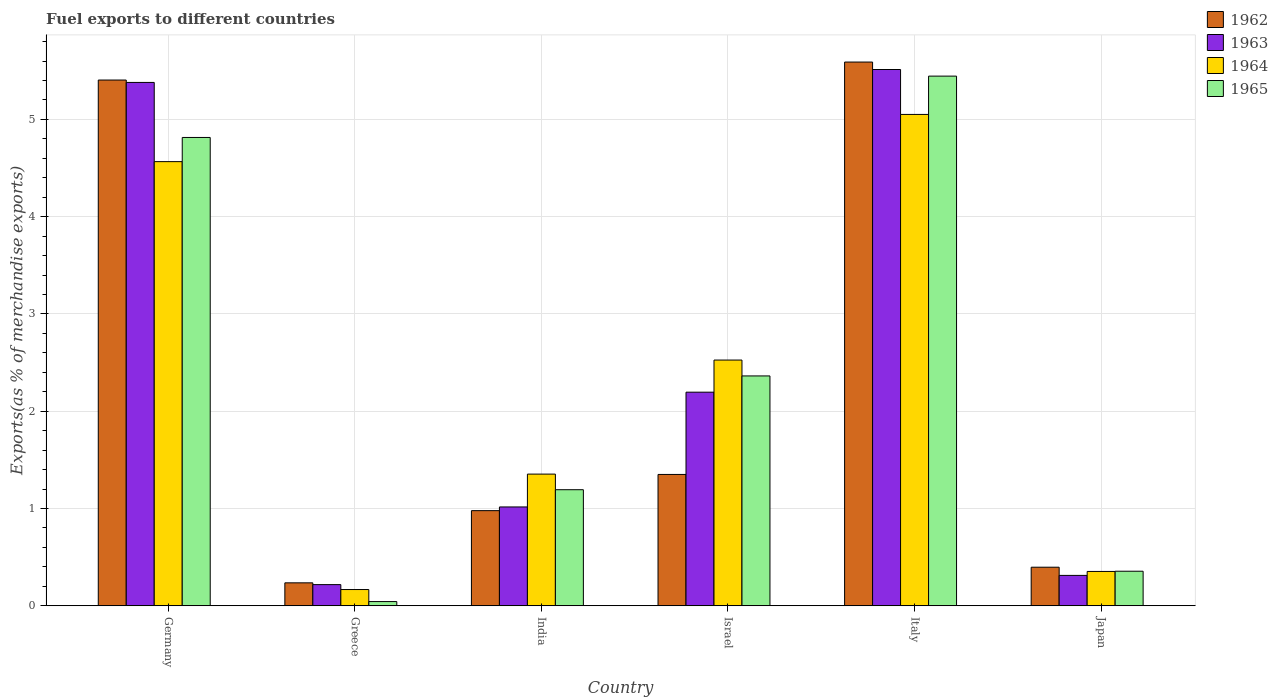Are the number of bars per tick equal to the number of legend labels?
Your response must be concise. Yes. How many bars are there on the 6th tick from the right?
Offer a very short reply. 4. What is the percentage of exports to different countries in 1965 in India?
Keep it short and to the point. 1.19. Across all countries, what is the maximum percentage of exports to different countries in 1963?
Your answer should be very brief. 5.51. Across all countries, what is the minimum percentage of exports to different countries in 1965?
Your answer should be compact. 0.04. In which country was the percentage of exports to different countries in 1962 maximum?
Make the answer very short. Italy. What is the total percentage of exports to different countries in 1965 in the graph?
Ensure brevity in your answer.  14.21. What is the difference between the percentage of exports to different countries in 1962 in Greece and that in Italy?
Your answer should be very brief. -5.35. What is the difference between the percentage of exports to different countries in 1964 in Italy and the percentage of exports to different countries in 1963 in India?
Provide a succinct answer. 4.04. What is the average percentage of exports to different countries in 1962 per country?
Provide a short and direct response. 2.33. What is the difference between the percentage of exports to different countries of/in 1964 and percentage of exports to different countries of/in 1963 in Israel?
Keep it short and to the point. 0.33. What is the ratio of the percentage of exports to different countries in 1965 in Israel to that in Japan?
Your answer should be compact. 6.65. Is the percentage of exports to different countries in 1962 in Germany less than that in India?
Keep it short and to the point. No. Is the difference between the percentage of exports to different countries in 1964 in India and Japan greater than the difference between the percentage of exports to different countries in 1963 in India and Japan?
Provide a short and direct response. Yes. What is the difference between the highest and the second highest percentage of exports to different countries in 1963?
Offer a terse response. 3.18. What is the difference between the highest and the lowest percentage of exports to different countries in 1963?
Give a very brief answer. 5.3. In how many countries, is the percentage of exports to different countries in 1962 greater than the average percentage of exports to different countries in 1962 taken over all countries?
Offer a terse response. 2. Is the sum of the percentage of exports to different countries in 1964 in Germany and Japan greater than the maximum percentage of exports to different countries in 1963 across all countries?
Ensure brevity in your answer.  No. What does the 1st bar from the left in Israel represents?
Ensure brevity in your answer.  1962. What does the 3rd bar from the right in Germany represents?
Provide a short and direct response. 1963. How many bars are there?
Your answer should be very brief. 24. How many countries are there in the graph?
Your answer should be very brief. 6. Are the values on the major ticks of Y-axis written in scientific E-notation?
Provide a short and direct response. No. Does the graph contain any zero values?
Your answer should be very brief. No. Where does the legend appear in the graph?
Make the answer very short. Top right. How many legend labels are there?
Keep it short and to the point. 4. How are the legend labels stacked?
Your answer should be compact. Vertical. What is the title of the graph?
Your answer should be very brief. Fuel exports to different countries. What is the label or title of the X-axis?
Make the answer very short. Country. What is the label or title of the Y-axis?
Your answer should be compact. Exports(as % of merchandise exports). What is the Exports(as % of merchandise exports) of 1962 in Germany?
Your answer should be very brief. 5.4. What is the Exports(as % of merchandise exports) in 1963 in Germany?
Give a very brief answer. 5.38. What is the Exports(as % of merchandise exports) in 1964 in Germany?
Give a very brief answer. 4.57. What is the Exports(as % of merchandise exports) in 1965 in Germany?
Offer a very short reply. 4.81. What is the Exports(as % of merchandise exports) in 1962 in Greece?
Offer a terse response. 0.24. What is the Exports(as % of merchandise exports) in 1963 in Greece?
Offer a very short reply. 0.22. What is the Exports(as % of merchandise exports) in 1964 in Greece?
Your answer should be very brief. 0.17. What is the Exports(as % of merchandise exports) in 1965 in Greece?
Keep it short and to the point. 0.04. What is the Exports(as % of merchandise exports) in 1962 in India?
Offer a very short reply. 0.98. What is the Exports(as % of merchandise exports) of 1963 in India?
Keep it short and to the point. 1.02. What is the Exports(as % of merchandise exports) of 1964 in India?
Give a very brief answer. 1.35. What is the Exports(as % of merchandise exports) of 1965 in India?
Make the answer very short. 1.19. What is the Exports(as % of merchandise exports) in 1962 in Israel?
Provide a succinct answer. 1.35. What is the Exports(as % of merchandise exports) of 1963 in Israel?
Make the answer very short. 2.2. What is the Exports(as % of merchandise exports) in 1964 in Israel?
Provide a succinct answer. 2.53. What is the Exports(as % of merchandise exports) of 1965 in Israel?
Provide a short and direct response. 2.36. What is the Exports(as % of merchandise exports) of 1962 in Italy?
Keep it short and to the point. 5.59. What is the Exports(as % of merchandise exports) in 1963 in Italy?
Your answer should be very brief. 5.51. What is the Exports(as % of merchandise exports) of 1964 in Italy?
Keep it short and to the point. 5.05. What is the Exports(as % of merchandise exports) in 1965 in Italy?
Keep it short and to the point. 5.45. What is the Exports(as % of merchandise exports) in 1962 in Japan?
Offer a very short reply. 0.4. What is the Exports(as % of merchandise exports) in 1963 in Japan?
Give a very brief answer. 0.31. What is the Exports(as % of merchandise exports) in 1964 in Japan?
Your answer should be compact. 0.35. What is the Exports(as % of merchandise exports) in 1965 in Japan?
Give a very brief answer. 0.36. Across all countries, what is the maximum Exports(as % of merchandise exports) of 1962?
Ensure brevity in your answer.  5.59. Across all countries, what is the maximum Exports(as % of merchandise exports) in 1963?
Keep it short and to the point. 5.51. Across all countries, what is the maximum Exports(as % of merchandise exports) of 1964?
Ensure brevity in your answer.  5.05. Across all countries, what is the maximum Exports(as % of merchandise exports) of 1965?
Your answer should be compact. 5.45. Across all countries, what is the minimum Exports(as % of merchandise exports) in 1962?
Provide a short and direct response. 0.24. Across all countries, what is the minimum Exports(as % of merchandise exports) of 1963?
Your answer should be very brief. 0.22. Across all countries, what is the minimum Exports(as % of merchandise exports) of 1964?
Keep it short and to the point. 0.17. Across all countries, what is the minimum Exports(as % of merchandise exports) in 1965?
Make the answer very short. 0.04. What is the total Exports(as % of merchandise exports) in 1962 in the graph?
Offer a terse response. 13.96. What is the total Exports(as % of merchandise exports) of 1963 in the graph?
Your response must be concise. 14.64. What is the total Exports(as % of merchandise exports) in 1964 in the graph?
Provide a succinct answer. 14.02. What is the total Exports(as % of merchandise exports) of 1965 in the graph?
Provide a short and direct response. 14.21. What is the difference between the Exports(as % of merchandise exports) of 1962 in Germany and that in Greece?
Ensure brevity in your answer.  5.17. What is the difference between the Exports(as % of merchandise exports) of 1963 in Germany and that in Greece?
Offer a very short reply. 5.16. What is the difference between the Exports(as % of merchandise exports) of 1964 in Germany and that in Greece?
Give a very brief answer. 4.4. What is the difference between the Exports(as % of merchandise exports) of 1965 in Germany and that in Greece?
Your answer should be very brief. 4.77. What is the difference between the Exports(as % of merchandise exports) of 1962 in Germany and that in India?
Offer a very short reply. 4.43. What is the difference between the Exports(as % of merchandise exports) in 1963 in Germany and that in India?
Ensure brevity in your answer.  4.36. What is the difference between the Exports(as % of merchandise exports) of 1964 in Germany and that in India?
Ensure brevity in your answer.  3.21. What is the difference between the Exports(as % of merchandise exports) of 1965 in Germany and that in India?
Make the answer very short. 3.62. What is the difference between the Exports(as % of merchandise exports) of 1962 in Germany and that in Israel?
Your answer should be compact. 4.05. What is the difference between the Exports(as % of merchandise exports) of 1963 in Germany and that in Israel?
Offer a terse response. 3.18. What is the difference between the Exports(as % of merchandise exports) of 1964 in Germany and that in Israel?
Ensure brevity in your answer.  2.04. What is the difference between the Exports(as % of merchandise exports) in 1965 in Germany and that in Israel?
Ensure brevity in your answer.  2.45. What is the difference between the Exports(as % of merchandise exports) in 1962 in Germany and that in Italy?
Provide a short and direct response. -0.18. What is the difference between the Exports(as % of merchandise exports) in 1963 in Germany and that in Italy?
Your answer should be very brief. -0.13. What is the difference between the Exports(as % of merchandise exports) of 1964 in Germany and that in Italy?
Give a very brief answer. -0.49. What is the difference between the Exports(as % of merchandise exports) in 1965 in Germany and that in Italy?
Make the answer very short. -0.63. What is the difference between the Exports(as % of merchandise exports) of 1962 in Germany and that in Japan?
Your answer should be compact. 5.01. What is the difference between the Exports(as % of merchandise exports) of 1963 in Germany and that in Japan?
Keep it short and to the point. 5.07. What is the difference between the Exports(as % of merchandise exports) of 1964 in Germany and that in Japan?
Your answer should be compact. 4.21. What is the difference between the Exports(as % of merchandise exports) in 1965 in Germany and that in Japan?
Provide a succinct answer. 4.46. What is the difference between the Exports(as % of merchandise exports) of 1962 in Greece and that in India?
Your answer should be compact. -0.74. What is the difference between the Exports(as % of merchandise exports) in 1963 in Greece and that in India?
Your response must be concise. -0.8. What is the difference between the Exports(as % of merchandise exports) in 1964 in Greece and that in India?
Your answer should be very brief. -1.19. What is the difference between the Exports(as % of merchandise exports) of 1965 in Greece and that in India?
Provide a succinct answer. -1.15. What is the difference between the Exports(as % of merchandise exports) of 1962 in Greece and that in Israel?
Offer a very short reply. -1.11. What is the difference between the Exports(as % of merchandise exports) of 1963 in Greece and that in Israel?
Give a very brief answer. -1.98. What is the difference between the Exports(as % of merchandise exports) of 1964 in Greece and that in Israel?
Your answer should be very brief. -2.36. What is the difference between the Exports(as % of merchandise exports) in 1965 in Greece and that in Israel?
Provide a succinct answer. -2.32. What is the difference between the Exports(as % of merchandise exports) in 1962 in Greece and that in Italy?
Offer a very short reply. -5.35. What is the difference between the Exports(as % of merchandise exports) in 1963 in Greece and that in Italy?
Your answer should be compact. -5.3. What is the difference between the Exports(as % of merchandise exports) in 1964 in Greece and that in Italy?
Give a very brief answer. -4.88. What is the difference between the Exports(as % of merchandise exports) in 1965 in Greece and that in Italy?
Offer a very short reply. -5.4. What is the difference between the Exports(as % of merchandise exports) in 1962 in Greece and that in Japan?
Keep it short and to the point. -0.16. What is the difference between the Exports(as % of merchandise exports) of 1963 in Greece and that in Japan?
Ensure brevity in your answer.  -0.09. What is the difference between the Exports(as % of merchandise exports) in 1964 in Greece and that in Japan?
Make the answer very short. -0.19. What is the difference between the Exports(as % of merchandise exports) of 1965 in Greece and that in Japan?
Your answer should be very brief. -0.31. What is the difference between the Exports(as % of merchandise exports) of 1962 in India and that in Israel?
Keep it short and to the point. -0.37. What is the difference between the Exports(as % of merchandise exports) in 1963 in India and that in Israel?
Provide a succinct answer. -1.18. What is the difference between the Exports(as % of merchandise exports) of 1964 in India and that in Israel?
Provide a succinct answer. -1.17. What is the difference between the Exports(as % of merchandise exports) in 1965 in India and that in Israel?
Your answer should be very brief. -1.17. What is the difference between the Exports(as % of merchandise exports) in 1962 in India and that in Italy?
Provide a short and direct response. -4.61. What is the difference between the Exports(as % of merchandise exports) in 1963 in India and that in Italy?
Your response must be concise. -4.5. What is the difference between the Exports(as % of merchandise exports) of 1964 in India and that in Italy?
Your answer should be compact. -3.7. What is the difference between the Exports(as % of merchandise exports) in 1965 in India and that in Italy?
Provide a short and direct response. -4.25. What is the difference between the Exports(as % of merchandise exports) in 1962 in India and that in Japan?
Ensure brevity in your answer.  0.58. What is the difference between the Exports(as % of merchandise exports) in 1963 in India and that in Japan?
Your answer should be very brief. 0.7. What is the difference between the Exports(as % of merchandise exports) in 1965 in India and that in Japan?
Offer a terse response. 0.84. What is the difference between the Exports(as % of merchandise exports) in 1962 in Israel and that in Italy?
Keep it short and to the point. -4.24. What is the difference between the Exports(as % of merchandise exports) of 1963 in Israel and that in Italy?
Your response must be concise. -3.32. What is the difference between the Exports(as % of merchandise exports) of 1964 in Israel and that in Italy?
Ensure brevity in your answer.  -2.53. What is the difference between the Exports(as % of merchandise exports) of 1965 in Israel and that in Italy?
Your answer should be compact. -3.08. What is the difference between the Exports(as % of merchandise exports) in 1962 in Israel and that in Japan?
Your answer should be compact. 0.95. What is the difference between the Exports(as % of merchandise exports) of 1963 in Israel and that in Japan?
Provide a short and direct response. 1.88. What is the difference between the Exports(as % of merchandise exports) of 1964 in Israel and that in Japan?
Make the answer very short. 2.17. What is the difference between the Exports(as % of merchandise exports) of 1965 in Israel and that in Japan?
Keep it short and to the point. 2.01. What is the difference between the Exports(as % of merchandise exports) of 1962 in Italy and that in Japan?
Your answer should be very brief. 5.19. What is the difference between the Exports(as % of merchandise exports) of 1963 in Italy and that in Japan?
Your answer should be compact. 5.2. What is the difference between the Exports(as % of merchandise exports) of 1964 in Italy and that in Japan?
Make the answer very short. 4.7. What is the difference between the Exports(as % of merchandise exports) in 1965 in Italy and that in Japan?
Give a very brief answer. 5.09. What is the difference between the Exports(as % of merchandise exports) in 1962 in Germany and the Exports(as % of merchandise exports) in 1963 in Greece?
Provide a succinct answer. 5.19. What is the difference between the Exports(as % of merchandise exports) in 1962 in Germany and the Exports(as % of merchandise exports) in 1964 in Greece?
Ensure brevity in your answer.  5.24. What is the difference between the Exports(as % of merchandise exports) of 1962 in Germany and the Exports(as % of merchandise exports) of 1965 in Greece?
Provide a short and direct response. 5.36. What is the difference between the Exports(as % of merchandise exports) of 1963 in Germany and the Exports(as % of merchandise exports) of 1964 in Greece?
Provide a short and direct response. 5.21. What is the difference between the Exports(as % of merchandise exports) in 1963 in Germany and the Exports(as % of merchandise exports) in 1965 in Greece?
Keep it short and to the point. 5.34. What is the difference between the Exports(as % of merchandise exports) in 1964 in Germany and the Exports(as % of merchandise exports) in 1965 in Greece?
Your answer should be very brief. 4.52. What is the difference between the Exports(as % of merchandise exports) of 1962 in Germany and the Exports(as % of merchandise exports) of 1963 in India?
Ensure brevity in your answer.  4.39. What is the difference between the Exports(as % of merchandise exports) of 1962 in Germany and the Exports(as % of merchandise exports) of 1964 in India?
Make the answer very short. 4.05. What is the difference between the Exports(as % of merchandise exports) of 1962 in Germany and the Exports(as % of merchandise exports) of 1965 in India?
Give a very brief answer. 4.21. What is the difference between the Exports(as % of merchandise exports) of 1963 in Germany and the Exports(as % of merchandise exports) of 1964 in India?
Provide a short and direct response. 4.03. What is the difference between the Exports(as % of merchandise exports) in 1963 in Germany and the Exports(as % of merchandise exports) in 1965 in India?
Keep it short and to the point. 4.19. What is the difference between the Exports(as % of merchandise exports) in 1964 in Germany and the Exports(as % of merchandise exports) in 1965 in India?
Ensure brevity in your answer.  3.37. What is the difference between the Exports(as % of merchandise exports) of 1962 in Germany and the Exports(as % of merchandise exports) of 1963 in Israel?
Provide a succinct answer. 3.21. What is the difference between the Exports(as % of merchandise exports) in 1962 in Germany and the Exports(as % of merchandise exports) in 1964 in Israel?
Your answer should be compact. 2.88. What is the difference between the Exports(as % of merchandise exports) in 1962 in Germany and the Exports(as % of merchandise exports) in 1965 in Israel?
Your response must be concise. 3.04. What is the difference between the Exports(as % of merchandise exports) in 1963 in Germany and the Exports(as % of merchandise exports) in 1964 in Israel?
Ensure brevity in your answer.  2.85. What is the difference between the Exports(as % of merchandise exports) of 1963 in Germany and the Exports(as % of merchandise exports) of 1965 in Israel?
Your response must be concise. 3.02. What is the difference between the Exports(as % of merchandise exports) of 1964 in Germany and the Exports(as % of merchandise exports) of 1965 in Israel?
Make the answer very short. 2.2. What is the difference between the Exports(as % of merchandise exports) of 1962 in Germany and the Exports(as % of merchandise exports) of 1963 in Italy?
Give a very brief answer. -0.11. What is the difference between the Exports(as % of merchandise exports) in 1962 in Germany and the Exports(as % of merchandise exports) in 1964 in Italy?
Keep it short and to the point. 0.35. What is the difference between the Exports(as % of merchandise exports) in 1962 in Germany and the Exports(as % of merchandise exports) in 1965 in Italy?
Keep it short and to the point. -0.04. What is the difference between the Exports(as % of merchandise exports) of 1963 in Germany and the Exports(as % of merchandise exports) of 1964 in Italy?
Offer a very short reply. 0.33. What is the difference between the Exports(as % of merchandise exports) of 1963 in Germany and the Exports(as % of merchandise exports) of 1965 in Italy?
Offer a very short reply. -0.06. What is the difference between the Exports(as % of merchandise exports) of 1964 in Germany and the Exports(as % of merchandise exports) of 1965 in Italy?
Your answer should be compact. -0.88. What is the difference between the Exports(as % of merchandise exports) of 1962 in Germany and the Exports(as % of merchandise exports) of 1963 in Japan?
Offer a very short reply. 5.09. What is the difference between the Exports(as % of merchandise exports) of 1962 in Germany and the Exports(as % of merchandise exports) of 1964 in Japan?
Your answer should be compact. 5.05. What is the difference between the Exports(as % of merchandise exports) in 1962 in Germany and the Exports(as % of merchandise exports) in 1965 in Japan?
Provide a short and direct response. 5.05. What is the difference between the Exports(as % of merchandise exports) of 1963 in Germany and the Exports(as % of merchandise exports) of 1964 in Japan?
Make the answer very short. 5.03. What is the difference between the Exports(as % of merchandise exports) of 1963 in Germany and the Exports(as % of merchandise exports) of 1965 in Japan?
Ensure brevity in your answer.  5.03. What is the difference between the Exports(as % of merchandise exports) in 1964 in Germany and the Exports(as % of merchandise exports) in 1965 in Japan?
Your answer should be compact. 4.21. What is the difference between the Exports(as % of merchandise exports) of 1962 in Greece and the Exports(as % of merchandise exports) of 1963 in India?
Make the answer very short. -0.78. What is the difference between the Exports(as % of merchandise exports) of 1962 in Greece and the Exports(as % of merchandise exports) of 1964 in India?
Offer a very short reply. -1.12. What is the difference between the Exports(as % of merchandise exports) in 1962 in Greece and the Exports(as % of merchandise exports) in 1965 in India?
Keep it short and to the point. -0.96. What is the difference between the Exports(as % of merchandise exports) of 1963 in Greece and the Exports(as % of merchandise exports) of 1964 in India?
Ensure brevity in your answer.  -1.14. What is the difference between the Exports(as % of merchandise exports) of 1963 in Greece and the Exports(as % of merchandise exports) of 1965 in India?
Provide a succinct answer. -0.98. What is the difference between the Exports(as % of merchandise exports) of 1964 in Greece and the Exports(as % of merchandise exports) of 1965 in India?
Offer a terse response. -1.03. What is the difference between the Exports(as % of merchandise exports) of 1962 in Greece and the Exports(as % of merchandise exports) of 1963 in Israel?
Make the answer very short. -1.96. What is the difference between the Exports(as % of merchandise exports) in 1962 in Greece and the Exports(as % of merchandise exports) in 1964 in Israel?
Give a very brief answer. -2.29. What is the difference between the Exports(as % of merchandise exports) in 1962 in Greece and the Exports(as % of merchandise exports) in 1965 in Israel?
Offer a terse response. -2.13. What is the difference between the Exports(as % of merchandise exports) in 1963 in Greece and the Exports(as % of merchandise exports) in 1964 in Israel?
Provide a succinct answer. -2.31. What is the difference between the Exports(as % of merchandise exports) in 1963 in Greece and the Exports(as % of merchandise exports) in 1965 in Israel?
Make the answer very short. -2.15. What is the difference between the Exports(as % of merchandise exports) in 1964 in Greece and the Exports(as % of merchandise exports) in 1965 in Israel?
Your response must be concise. -2.2. What is the difference between the Exports(as % of merchandise exports) in 1962 in Greece and the Exports(as % of merchandise exports) in 1963 in Italy?
Provide a succinct answer. -5.28. What is the difference between the Exports(as % of merchandise exports) in 1962 in Greece and the Exports(as % of merchandise exports) in 1964 in Italy?
Your answer should be compact. -4.82. What is the difference between the Exports(as % of merchandise exports) of 1962 in Greece and the Exports(as % of merchandise exports) of 1965 in Italy?
Make the answer very short. -5.21. What is the difference between the Exports(as % of merchandise exports) of 1963 in Greece and the Exports(as % of merchandise exports) of 1964 in Italy?
Your answer should be compact. -4.83. What is the difference between the Exports(as % of merchandise exports) of 1963 in Greece and the Exports(as % of merchandise exports) of 1965 in Italy?
Make the answer very short. -5.23. What is the difference between the Exports(as % of merchandise exports) of 1964 in Greece and the Exports(as % of merchandise exports) of 1965 in Italy?
Offer a very short reply. -5.28. What is the difference between the Exports(as % of merchandise exports) in 1962 in Greece and the Exports(as % of merchandise exports) in 1963 in Japan?
Provide a short and direct response. -0.08. What is the difference between the Exports(as % of merchandise exports) in 1962 in Greece and the Exports(as % of merchandise exports) in 1964 in Japan?
Give a very brief answer. -0.12. What is the difference between the Exports(as % of merchandise exports) of 1962 in Greece and the Exports(as % of merchandise exports) of 1965 in Japan?
Ensure brevity in your answer.  -0.12. What is the difference between the Exports(as % of merchandise exports) in 1963 in Greece and the Exports(as % of merchandise exports) in 1964 in Japan?
Give a very brief answer. -0.14. What is the difference between the Exports(as % of merchandise exports) in 1963 in Greece and the Exports(as % of merchandise exports) in 1965 in Japan?
Your answer should be very brief. -0.14. What is the difference between the Exports(as % of merchandise exports) in 1964 in Greece and the Exports(as % of merchandise exports) in 1965 in Japan?
Your answer should be compact. -0.19. What is the difference between the Exports(as % of merchandise exports) in 1962 in India and the Exports(as % of merchandise exports) in 1963 in Israel?
Keep it short and to the point. -1.22. What is the difference between the Exports(as % of merchandise exports) of 1962 in India and the Exports(as % of merchandise exports) of 1964 in Israel?
Provide a succinct answer. -1.55. What is the difference between the Exports(as % of merchandise exports) in 1962 in India and the Exports(as % of merchandise exports) in 1965 in Israel?
Offer a terse response. -1.38. What is the difference between the Exports(as % of merchandise exports) of 1963 in India and the Exports(as % of merchandise exports) of 1964 in Israel?
Give a very brief answer. -1.51. What is the difference between the Exports(as % of merchandise exports) in 1963 in India and the Exports(as % of merchandise exports) in 1965 in Israel?
Keep it short and to the point. -1.35. What is the difference between the Exports(as % of merchandise exports) of 1964 in India and the Exports(as % of merchandise exports) of 1965 in Israel?
Your response must be concise. -1.01. What is the difference between the Exports(as % of merchandise exports) in 1962 in India and the Exports(as % of merchandise exports) in 1963 in Italy?
Keep it short and to the point. -4.54. What is the difference between the Exports(as % of merchandise exports) of 1962 in India and the Exports(as % of merchandise exports) of 1964 in Italy?
Make the answer very short. -4.07. What is the difference between the Exports(as % of merchandise exports) in 1962 in India and the Exports(as % of merchandise exports) in 1965 in Italy?
Offer a terse response. -4.47. What is the difference between the Exports(as % of merchandise exports) in 1963 in India and the Exports(as % of merchandise exports) in 1964 in Italy?
Make the answer very short. -4.04. What is the difference between the Exports(as % of merchandise exports) of 1963 in India and the Exports(as % of merchandise exports) of 1965 in Italy?
Your answer should be very brief. -4.43. What is the difference between the Exports(as % of merchandise exports) in 1964 in India and the Exports(as % of merchandise exports) in 1965 in Italy?
Offer a terse response. -4.09. What is the difference between the Exports(as % of merchandise exports) in 1962 in India and the Exports(as % of merchandise exports) in 1963 in Japan?
Provide a short and direct response. 0.67. What is the difference between the Exports(as % of merchandise exports) in 1962 in India and the Exports(as % of merchandise exports) in 1964 in Japan?
Your answer should be very brief. 0.63. What is the difference between the Exports(as % of merchandise exports) in 1962 in India and the Exports(as % of merchandise exports) in 1965 in Japan?
Provide a short and direct response. 0.62. What is the difference between the Exports(as % of merchandise exports) in 1963 in India and the Exports(as % of merchandise exports) in 1964 in Japan?
Give a very brief answer. 0.66. What is the difference between the Exports(as % of merchandise exports) of 1963 in India and the Exports(as % of merchandise exports) of 1965 in Japan?
Provide a succinct answer. 0.66. What is the difference between the Exports(as % of merchandise exports) of 1964 in India and the Exports(as % of merchandise exports) of 1965 in Japan?
Keep it short and to the point. 1. What is the difference between the Exports(as % of merchandise exports) in 1962 in Israel and the Exports(as % of merchandise exports) in 1963 in Italy?
Offer a terse response. -4.16. What is the difference between the Exports(as % of merchandise exports) in 1962 in Israel and the Exports(as % of merchandise exports) in 1964 in Italy?
Your response must be concise. -3.7. What is the difference between the Exports(as % of merchandise exports) of 1962 in Israel and the Exports(as % of merchandise exports) of 1965 in Italy?
Offer a terse response. -4.09. What is the difference between the Exports(as % of merchandise exports) in 1963 in Israel and the Exports(as % of merchandise exports) in 1964 in Italy?
Provide a succinct answer. -2.86. What is the difference between the Exports(as % of merchandise exports) of 1963 in Israel and the Exports(as % of merchandise exports) of 1965 in Italy?
Offer a very short reply. -3.25. What is the difference between the Exports(as % of merchandise exports) in 1964 in Israel and the Exports(as % of merchandise exports) in 1965 in Italy?
Provide a succinct answer. -2.92. What is the difference between the Exports(as % of merchandise exports) in 1962 in Israel and the Exports(as % of merchandise exports) in 1963 in Japan?
Provide a short and direct response. 1.04. What is the difference between the Exports(as % of merchandise exports) in 1962 in Israel and the Exports(as % of merchandise exports) in 1964 in Japan?
Your answer should be very brief. 1. What is the difference between the Exports(as % of merchandise exports) in 1963 in Israel and the Exports(as % of merchandise exports) in 1964 in Japan?
Provide a short and direct response. 1.84. What is the difference between the Exports(as % of merchandise exports) in 1963 in Israel and the Exports(as % of merchandise exports) in 1965 in Japan?
Make the answer very short. 1.84. What is the difference between the Exports(as % of merchandise exports) of 1964 in Israel and the Exports(as % of merchandise exports) of 1965 in Japan?
Offer a terse response. 2.17. What is the difference between the Exports(as % of merchandise exports) in 1962 in Italy and the Exports(as % of merchandise exports) in 1963 in Japan?
Offer a terse response. 5.28. What is the difference between the Exports(as % of merchandise exports) in 1962 in Italy and the Exports(as % of merchandise exports) in 1964 in Japan?
Make the answer very short. 5.24. What is the difference between the Exports(as % of merchandise exports) of 1962 in Italy and the Exports(as % of merchandise exports) of 1965 in Japan?
Offer a terse response. 5.23. What is the difference between the Exports(as % of merchandise exports) of 1963 in Italy and the Exports(as % of merchandise exports) of 1964 in Japan?
Offer a terse response. 5.16. What is the difference between the Exports(as % of merchandise exports) in 1963 in Italy and the Exports(as % of merchandise exports) in 1965 in Japan?
Keep it short and to the point. 5.16. What is the difference between the Exports(as % of merchandise exports) of 1964 in Italy and the Exports(as % of merchandise exports) of 1965 in Japan?
Your answer should be very brief. 4.7. What is the average Exports(as % of merchandise exports) of 1962 per country?
Your answer should be very brief. 2.33. What is the average Exports(as % of merchandise exports) in 1963 per country?
Keep it short and to the point. 2.44. What is the average Exports(as % of merchandise exports) of 1964 per country?
Offer a terse response. 2.34. What is the average Exports(as % of merchandise exports) of 1965 per country?
Make the answer very short. 2.37. What is the difference between the Exports(as % of merchandise exports) in 1962 and Exports(as % of merchandise exports) in 1963 in Germany?
Your answer should be compact. 0.02. What is the difference between the Exports(as % of merchandise exports) in 1962 and Exports(as % of merchandise exports) in 1964 in Germany?
Make the answer very short. 0.84. What is the difference between the Exports(as % of merchandise exports) of 1962 and Exports(as % of merchandise exports) of 1965 in Germany?
Make the answer very short. 0.59. What is the difference between the Exports(as % of merchandise exports) of 1963 and Exports(as % of merchandise exports) of 1964 in Germany?
Provide a short and direct response. 0.81. What is the difference between the Exports(as % of merchandise exports) in 1963 and Exports(as % of merchandise exports) in 1965 in Germany?
Keep it short and to the point. 0.57. What is the difference between the Exports(as % of merchandise exports) in 1964 and Exports(as % of merchandise exports) in 1965 in Germany?
Make the answer very short. -0.25. What is the difference between the Exports(as % of merchandise exports) in 1962 and Exports(as % of merchandise exports) in 1963 in Greece?
Your answer should be compact. 0.02. What is the difference between the Exports(as % of merchandise exports) in 1962 and Exports(as % of merchandise exports) in 1964 in Greece?
Ensure brevity in your answer.  0.07. What is the difference between the Exports(as % of merchandise exports) of 1962 and Exports(as % of merchandise exports) of 1965 in Greece?
Your response must be concise. 0.19. What is the difference between the Exports(as % of merchandise exports) of 1963 and Exports(as % of merchandise exports) of 1964 in Greece?
Ensure brevity in your answer.  0.05. What is the difference between the Exports(as % of merchandise exports) in 1963 and Exports(as % of merchandise exports) in 1965 in Greece?
Provide a short and direct response. 0.17. What is the difference between the Exports(as % of merchandise exports) of 1964 and Exports(as % of merchandise exports) of 1965 in Greece?
Offer a terse response. 0.12. What is the difference between the Exports(as % of merchandise exports) of 1962 and Exports(as % of merchandise exports) of 1963 in India?
Provide a short and direct response. -0.04. What is the difference between the Exports(as % of merchandise exports) in 1962 and Exports(as % of merchandise exports) in 1964 in India?
Ensure brevity in your answer.  -0.38. What is the difference between the Exports(as % of merchandise exports) of 1962 and Exports(as % of merchandise exports) of 1965 in India?
Provide a succinct answer. -0.22. What is the difference between the Exports(as % of merchandise exports) of 1963 and Exports(as % of merchandise exports) of 1964 in India?
Your answer should be compact. -0.34. What is the difference between the Exports(as % of merchandise exports) in 1963 and Exports(as % of merchandise exports) in 1965 in India?
Keep it short and to the point. -0.18. What is the difference between the Exports(as % of merchandise exports) of 1964 and Exports(as % of merchandise exports) of 1965 in India?
Provide a succinct answer. 0.16. What is the difference between the Exports(as % of merchandise exports) of 1962 and Exports(as % of merchandise exports) of 1963 in Israel?
Your response must be concise. -0.85. What is the difference between the Exports(as % of merchandise exports) of 1962 and Exports(as % of merchandise exports) of 1964 in Israel?
Your response must be concise. -1.18. What is the difference between the Exports(as % of merchandise exports) in 1962 and Exports(as % of merchandise exports) in 1965 in Israel?
Keep it short and to the point. -1.01. What is the difference between the Exports(as % of merchandise exports) in 1963 and Exports(as % of merchandise exports) in 1964 in Israel?
Make the answer very short. -0.33. What is the difference between the Exports(as % of merchandise exports) of 1963 and Exports(as % of merchandise exports) of 1965 in Israel?
Offer a very short reply. -0.17. What is the difference between the Exports(as % of merchandise exports) in 1964 and Exports(as % of merchandise exports) in 1965 in Israel?
Give a very brief answer. 0.16. What is the difference between the Exports(as % of merchandise exports) in 1962 and Exports(as % of merchandise exports) in 1963 in Italy?
Offer a very short reply. 0.08. What is the difference between the Exports(as % of merchandise exports) of 1962 and Exports(as % of merchandise exports) of 1964 in Italy?
Ensure brevity in your answer.  0.54. What is the difference between the Exports(as % of merchandise exports) in 1962 and Exports(as % of merchandise exports) in 1965 in Italy?
Provide a short and direct response. 0.14. What is the difference between the Exports(as % of merchandise exports) in 1963 and Exports(as % of merchandise exports) in 1964 in Italy?
Give a very brief answer. 0.46. What is the difference between the Exports(as % of merchandise exports) of 1963 and Exports(as % of merchandise exports) of 1965 in Italy?
Your answer should be compact. 0.07. What is the difference between the Exports(as % of merchandise exports) of 1964 and Exports(as % of merchandise exports) of 1965 in Italy?
Ensure brevity in your answer.  -0.39. What is the difference between the Exports(as % of merchandise exports) of 1962 and Exports(as % of merchandise exports) of 1963 in Japan?
Ensure brevity in your answer.  0.08. What is the difference between the Exports(as % of merchandise exports) of 1962 and Exports(as % of merchandise exports) of 1964 in Japan?
Make the answer very short. 0.04. What is the difference between the Exports(as % of merchandise exports) in 1962 and Exports(as % of merchandise exports) in 1965 in Japan?
Your answer should be very brief. 0.04. What is the difference between the Exports(as % of merchandise exports) in 1963 and Exports(as % of merchandise exports) in 1964 in Japan?
Ensure brevity in your answer.  -0.04. What is the difference between the Exports(as % of merchandise exports) in 1963 and Exports(as % of merchandise exports) in 1965 in Japan?
Your answer should be very brief. -0.04. What is the difference between the Exports(as % of merchandise exports) in 1964 and Exports(as % of merchandise exports) in 1965 in Japan?
Provide a succinct answer. -0. What is the ratio of the Exports(as % of merchandise exports) in 1962 in Germany to that in Greece?
Offer a terse response. 22.91. What is the ratio of the Exports(as % of merchandise exports) of 1963 in Germany to that in Greece?
Provide a short and direct response. 24.71. What is the ratio of the Exports(as % of merchandise exports) of 1964 in Germany to that in Greece?
Your answer should be very brief. 27.34. What is the ratio of the Exports(as % of merchandise exports) of 1965 in Germany to that in Greece?
Provide a succinct answer. 110.96. What is the ratio of the Exports(as % of merchandise exports) in 1962 in Germany to that in India?
Provide a short and direct response. 5.53. What is the ratio of the Exports(as % of merchandise exports) in 1963 in Germany to that in India?
Your answer should be very brief. 5.3. What is the ratio of the Exports(as % of merchandise exports) in 1964 in Germany to that in India?
Keep it short and to the point. 3.37. What is the ratio of the Exports(as % of merchandise exports) of 1965 in Germany to that in India?
Make the answer very short. 4.03. What is the ratio of the Exports(as % of merchandise exports) in 1962 in Germany to that in Israel?
Provide a succinct answer. 4. What is the ratio of the Exports(as % of merchandise exports) of 1963 in Germany to that in Israel?
Give a very brief answer. 2.45. What is the ratio of the Exports(as % of merchandise exports) in 1964 in Germany to that in Israel?
Keep it short and to the point. 1.81. What is the ratio of the Exports(as % of merchandise exports) in 1965 in Germany to that in Israel?
Keep it short and to the point. 2.04. What is the ratio of the Exports(as % of merchandise exports) in 1962 in Germany to that in Italy?
Offer a very short reply. 0.97. What is the ratio of the Exports(as % of merchandise exports) of 1963 in Germany to that in Italy?
Provide a succinct answer. 0.98. What is the ratio of the Exports(as % of merchandise exports) of 1964 in Germany to that in Italy?
Provide a short and direct response. 0.9. What is the ratio of the Exports(as % of merchandise exports) in 1965 in Germany to that in Italy?
Your response must be concise. 0.88. What is the ratio of the Exports(as % of merchandise exports) of 1962 in Germany to that in Japan?
Make the answer very short. 13.63. What is the ratio of the Exports(as % of merchandise exports) in 1963 in Germany to that in Japan?
Make the answer very short. 17.22. What is the ratio of the Exports(as % of merchandise exports) in 1964 in Germany to that in Japan?
Offer a terse response. 12.93. What is the ratio of the Exports(as % of merchandise exports) of 1965 in Germany to that in Japan?
Offer a terse response. 13.55. What is the ratio of the Exports(as % of merchandise exports) in 1962 in Greece to that in India?
Give a very brief answer. 0.24. What is the ratio of the Exports(as % of merchandise exports) of 1963 in Greece to that in India?
Make the answer very short. 0.21. What is the ratio of the Exports(as % of merchandise exports) of 1964 in Greece to that in India?
Offer a terse response. 0.12. What is the ratio of the Exports(as % of merchandise exports) in 1965 in Greece to that in India?
Offer a terse response. 0.04. What is the ratio of the Exports(as % of merchandise exports) in 1962 in Greece to that in Israel?
Make the answer very short. 0.17. What is the ratio of the Exports(as % of merchandise exports) in 1963 in Greece to that in Israel?
Your answer should be very brief. 0.1. What is the ratio of the Exports(as % of merchandise exports) in 1964 in Greece to that in Israel?
Keep it short and to the point. 0.07. What is the ratio of the Exports(as % of merchandise exports) of 1965 in Greece to that in Israel?
Provide a short and direct response. 0.02. What is the ratio of the Exports(as % of merchandise exports) in 1962 in Greece to that in Italy?
Make the answer very short. 0.04. What is the ratio of the Exports(as % of merchandise exports) in 1963 in Greece to that in Italy?
Give a very brief answer. 0.04. What is the ratio of the Exports(as % of merchandise exports) of 1964 in Greece to that in Italy?
Provide a succinct answer. 0.03. What is the ratio of the Exports(as % of merchandise exports) in 1965 in Greece to that in Italy?
Offer a very short reply. 0.01. What is the ratio of the Exports(as % of merchandise exports) in 1962 in Greece to that in Japan?
Keep it short and to the point. 0.59. What is the ratio of the Exports(as % of merchandise exports) of 1963 in Greece to that in Japan?
Offer a very short reply. 0.7. What is the ratio of the Exports(as % of merchandise exports) in 1964 in Greece to that in Japan?
Your response must be concise. 0.47. What is the ratio of the Exports(as % of merchandise exports) of 1965 in Greece to that in Japan?
Offer a very short reply. 0.12. What is the ratio of the Exports(as % of merchandise exports) in 1962 in India to that in Israel?
Your response must be concise. 0.72. What is the ratio of the Exports(as % of merchandise exports) of 1963 in India to that in Israel?
Keep it short and to the point. 0.46. What is the ratio of the Exports(as % of merchandise exports) of 1964 in India to that in Israel?
Ensure brevity in your answer.  0.54. What is the ratio of the Exports(as % of merchandise exports) of 1965 in India to that in Israel?
Offer a very short reply. 0.51. What is the ratio of the Exports(as % of merchandise exports) in 1962 in India to that in Italy?
Provide a short and direct response. 0.17. What is the ratio of the Exports(as % of merchandise exports) in 1963 in India to that in Italy?
Provide a short and direct response. 0.18. What is the ratio of the Exports(as % of merchandise exports) of 1964 in India to that in Italy?
Your answer should be compact. 0.27. What is the ratio of the Exports(as % of merchandise exports) of 1965 in India to that in Italy?
Your answer should be very brief. 0.22. What is the ratio of the Exports(as % of merchandise exports) in 1962 in India to that in Japan?
Provide a succinct answer. 2.47. What is the ratio of the Exports(as % of merchandise exports) in 1963 in India to that in Japan?
Your response must be concise. 3.25. What is the ratio of the Exports(as % of merchandise exports) in 1964 in India to that in Japan?
Ensure brevity in your answer.  3.83. What is the ratio of the Exports(as % of merchandise exports) in 1965 in India to that in Japan?
Ensure brevity in your answer.  3.36. What is the ratio of the Exports(as % of merchandise exports) in 1962 in Israel to that in Italy?
Ensure brevity in your answer.  0.24. What is the ratio of the Exports(as % of merchandise exports) in 1963 in Israel to that in Italy?
Your answer should be compact. 0.4. What is the ratio of the Exports(as % of merchandise exports) of 1964 in Israel to that in Italy?
Provide a short and direct response. 0.5. What is the ratio of the Exports(as % of merchandise exports) in 1965 in Israel to that in Italy?
Offer a very short reply. 0.43. What is the ratio of the Exports(as % of merchandise exports) of 1962 in Israel to that in Japan?
Offer a terse response. 3.4. What is the ratio of the Exports(as % of merchandise exports) in 1963 in Israel to that in Japan?
Offer a very short reply. 7.03. What is the ratio of the Exports(as % of merchandise exports) of 1964 in Israel to that in Japan?
Provide a succinct answer. 7.16. What is the ratio of the Exports(as % of merchandise exports) in 1965 in Israel to that in Japan?
Offer a terse response. 6.65. What is the ratio of the Exports(as % of merchandise exports) of 1962 in Italy to that in Japan?
Give a very brief answer. 14.1. What is the ratio of the Exports(as % of merchandise exports) in 1963 in Italy to that in Japan?
Give a very brief answer. 17.64. What is the ratio of the Exports(as % of merchandise exports) in 1964 in Italy to that in Japan?
Your response must be concise. 14.31. What is the ratio of the Exports(as % of merchandise exports) in 1965 in Italy to that in Japan?
Provide a short and direct response. 15.32. What is the difference between the highest and the second highest Exports(as % of merchandise exports) of 1962?
Provide a succinct answer. 0.18. What is the difference between the highest and the second highest Exports(as % of merchandise exports) in 1963?
Make the answer very short. 0.13. What is the difference between the highest and the second highest Exports(as % of merchandise exports) in 1964?
Provide a short and direct response. 0.49. What is the difference between the highest and the second highest Exports(as % of merchandise exports) of 1965?
Offer a terse response. 0.63. What is the difference between the highest and the lowest Exports(as % of merchandise exports) in 1962?
Make the answer very short. 5.35. What is the difference between the highest and the lowest Exports(as % of merchandise exports) of 1963?
Provide a succinct answer. 5.3. What is the difference between the highest and the lowest Exports(as % of merchandise exports) of 1964?
Provide a succinct answer. 4.88. What is the difference between the highest and the lowest Exports(as % of merchandise exports) of 1965?
Make the answer very short. 5.4. 